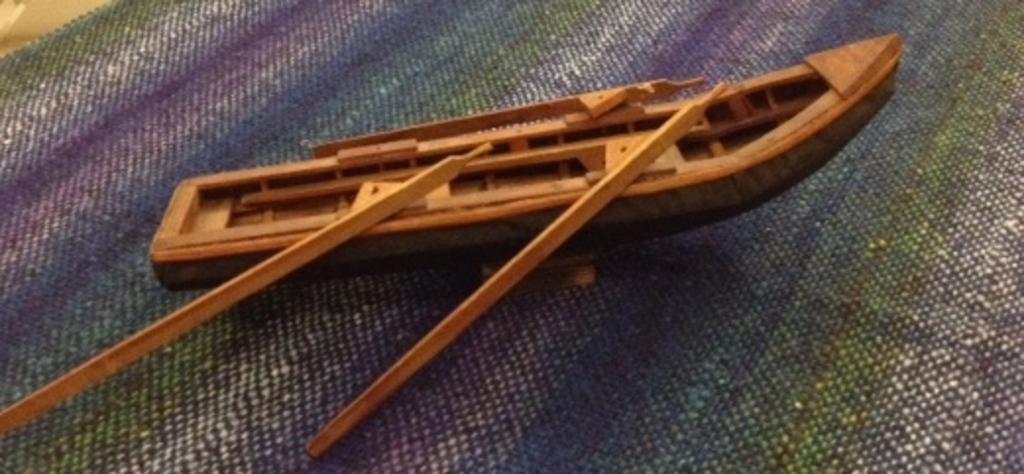Describe this image in one or two sentences. In the picture there is a toy of a boat with the two rows present on it which is present on the blanket. 